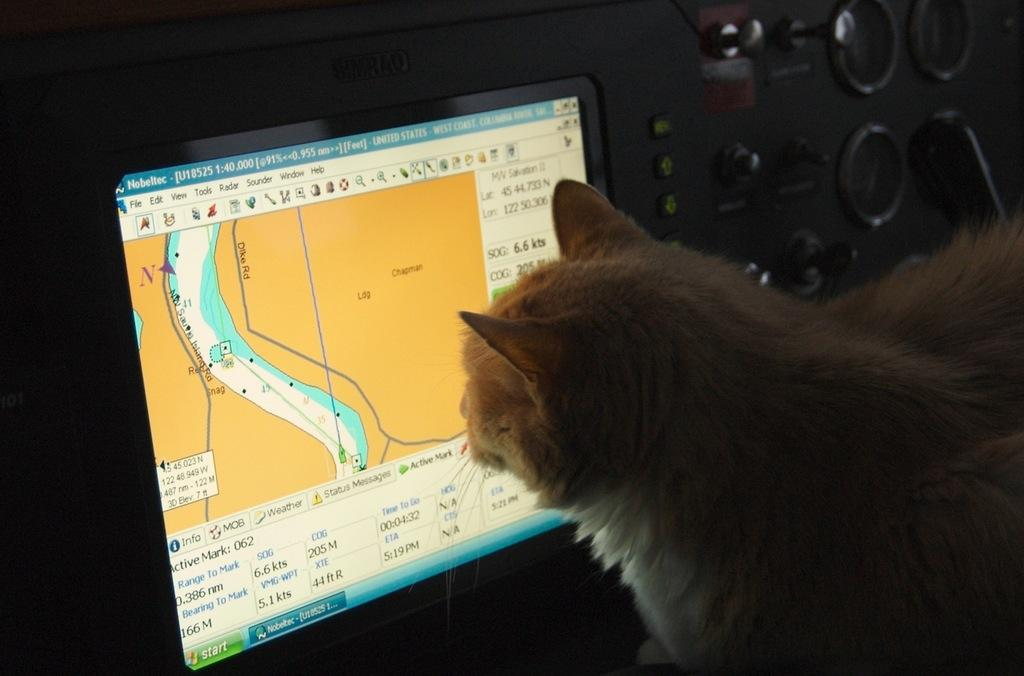What type of animal is in the image? There is a cat in the image. What other object can be seen in the image? There is an electronic device in the image. What feature of the electronic device is visible? There is a screen in the image. What type of prose is the cat reading on the screen? There is no indication that the cat is reading any prose, as cats do not read. Additionally, the image does not show any text on the screen. 